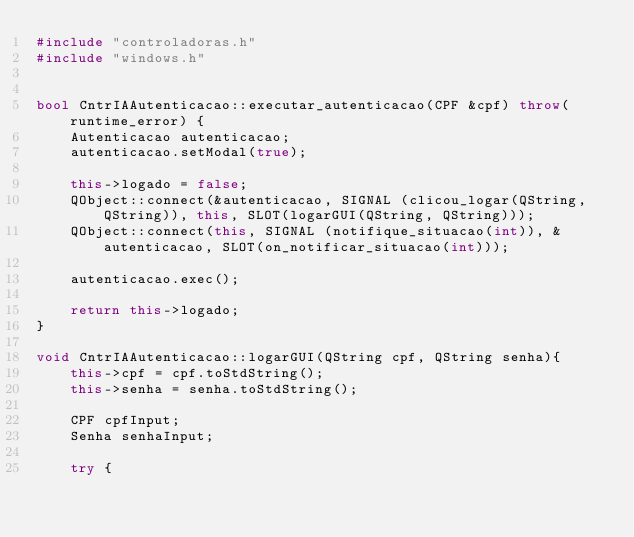<code> <loc_0><loc_0><loc_500><loc_500><_C++_>#include "controladoras.h"
#include "windows.h"


bool CntrIAAutenticacao::executar_autenticacao(CPF &cpf) throw(runtime_error) {
    Autenticacao autenticacao;
    autenticacao.setModal(true);

    this->logado = false;
    QObject::connect(&autenticacao, SIGNAL (clicou_logar(QString, QString)), this, SLOT(logarGUI(QString, QString)));
    QObject::connect(this, SIGNAL (notifique_situacao(int)), &autenticacao, SLOT(on_notificar_situacao(int)));

    autenticacao.exec();

    return this->logado;
}

void CntrIAAutenticacao::logarGUI(QString cpf, QString senha){
    this->cpf = cpf.toStdString();
    this->senha = senha.toStdString();

    CPF cpfInput;
    Senha senhaInput;

    try {</code> 